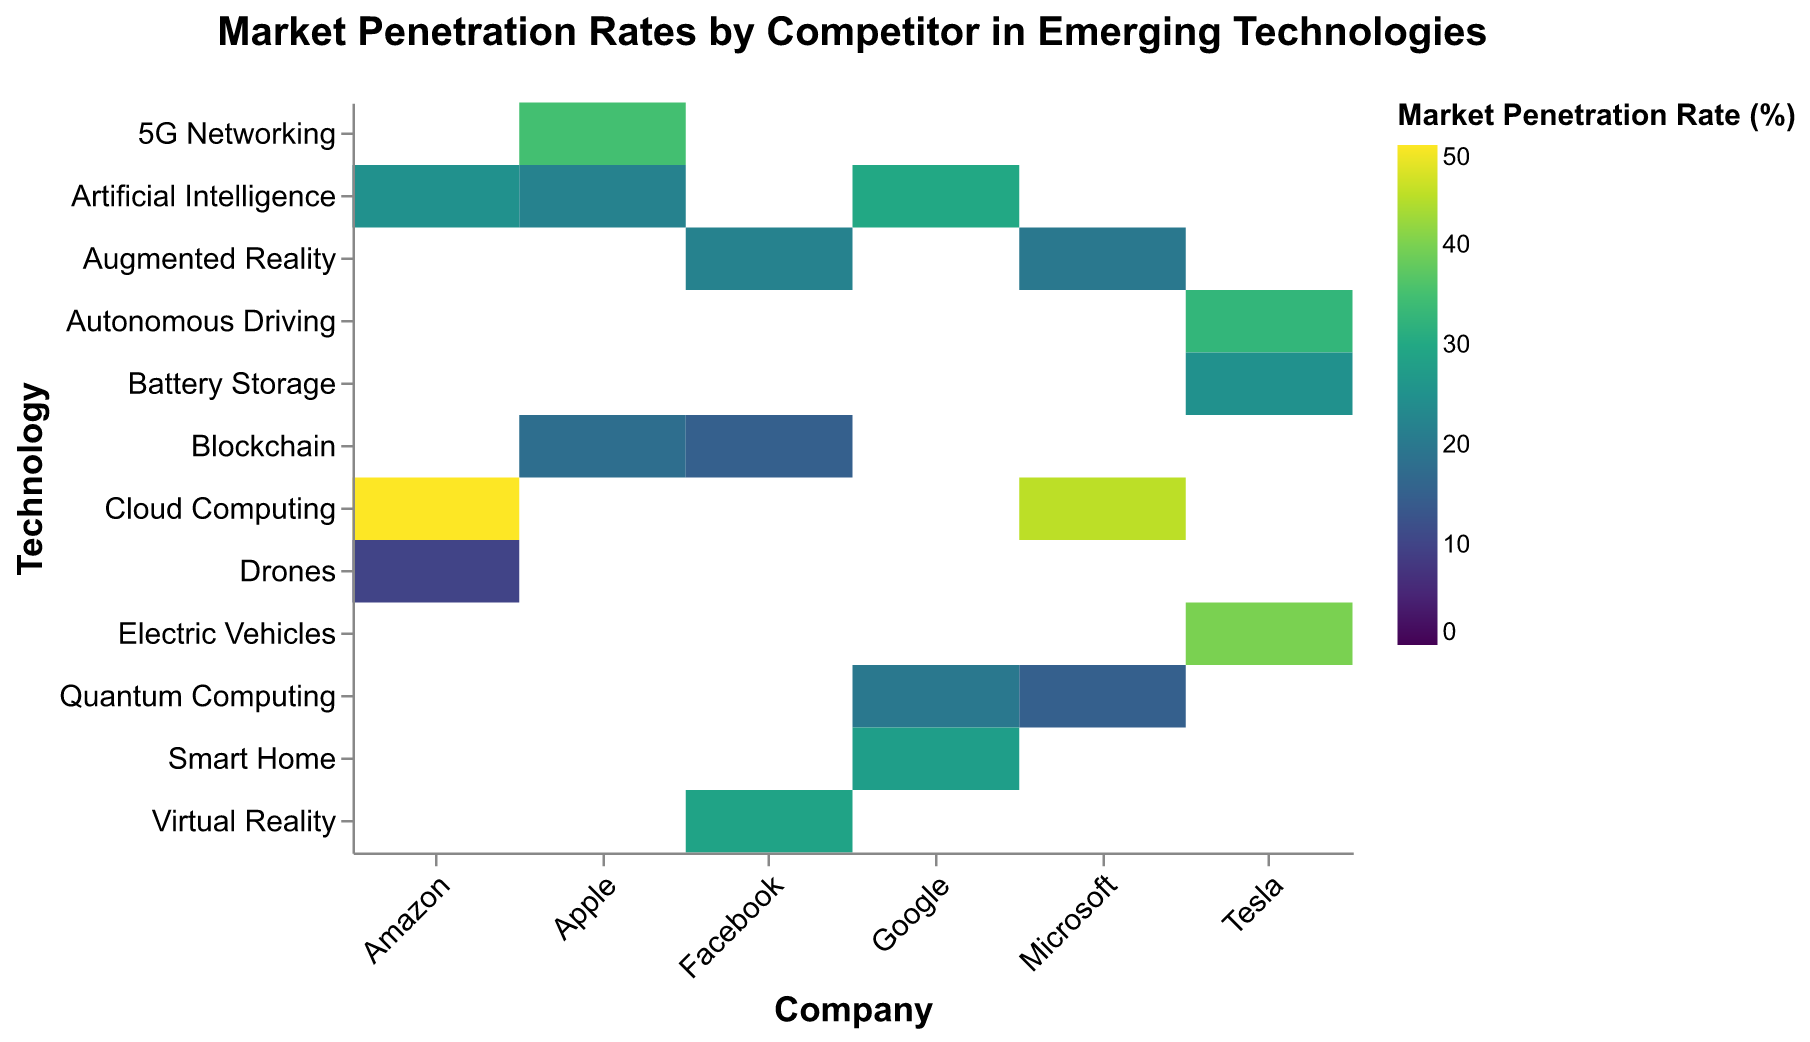What's the company with the highest market penetration rate in Cloud Computing? The heatmap shows that Amazon has the highest Market Penetration Rate for Cloud Computing at 50%.
Answer: Amazon Which emerging technology has Apple penetrated the most? The heatmap indicates that Apple's highest Market Penetration Rate is in 5G Networking at 35%.
Answer: 5G Networking What is the market penetration rate for Tesla in Autonomous Driving? By locating Tesla on the x-axis and Autonomous Driving on the y-axis, the heatmap shows a penetration rate of 33%.
Answer: 33% Compare the market penetration rates of Google and Microsoft in Quantum Computing. Which company has a higher rate? Comparing the heatmap values, Microsoft has a 15% penetration rate while Google has a 20% penetration rate in Quantum Computing. Hence, Google has a higher penetration rate.
Answer: Google How does Facebook's penetration in Virtual Reality compare to Amazon's penetration in Drones? Facebook has a penetration rate of 29% in Virtual Reality, while Amazon has a 10% penetration rate in Drones. Therefore, Facebook's rate is higher.
Answer: Facebook Between Tesla and Microsoft, which company has the highest overall market penetration rate in any technology? Tesla has a 40% penetration rate in Electric Vehicles, while Microsoft has a 45% in Cloud Computing. Thus, Microsoft's rate is higher.
Answer: Microsoft What's the average market penetration rate for Apple across all its technologies? Apple's values are 35%, 22%, and 18%. Adding these gives 35 + 22 + 18 = 75, and the average is 75/3 = 25.
Answer: 25 Which company has the lowest market penetration rate listed, and what is it? Amazon has the lowest market penetration rate in Drones, at 10%.
Answer: Amazon What is the total market penetration rate for Artificial Intelligence when considering all companies? Summing the market penetration rates for Artificial Intelligence: Apple (22%) + Google (30%) + Amazon (25%) = 77%.
Answer: 77 How does the market penetration rate of Electric Vehicles by Tesla compare to all other technologies by Tesla? Tesla's Electric Vehicles have a 40% penetration rate, which is higher than Autonomous Driving (33%) and Battery Storage (25%).
Answer: It's the highest among Tesla's technologies 